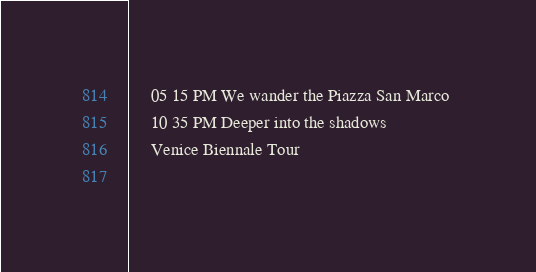Convert code to text. <code><loc_0><loc_0><loc_500><loc_500><_XML_>	 05 15 PM We wander the Piazza San Marco 
	 10 35 PM Deeper into the shadows 
	 Venice Biennale Tour 
	  
</code> 